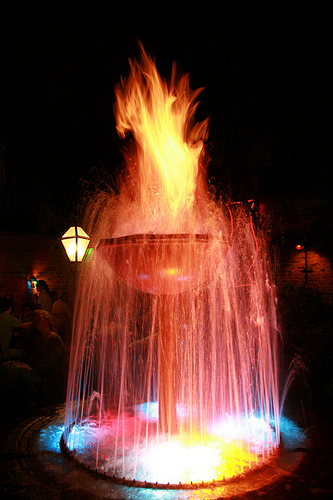<image>
Is the fire on the ground? No. The fire is not positioned on the ground. They may be near each other, but the fire is not supported by or resting on top of the ground. 